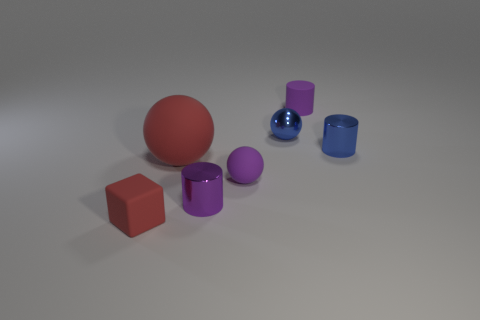Subtract all red spheres. How many spheres are left? 2 Add 2 tiny matte things. How many objects exist? 9 Subtract all purple cylinders. How many cylinders are left? 1 Subtract 2 spheres. How many spheres are left? 1 Subtract 0 brown cylinders. How many objects are left? 7 Subtract all spheres. How many objects are left? 4 Subtract all cyan balls. Subtract all cyan cylinders. How many balls are left? 3 Subtract all purple blocks. How many red balls are left? 1 Subtract all purple metallic cylinders. Subtract all blue spheres. How many objects are left? 5 Add 7 cylinders. How many cylinders are left? 10 